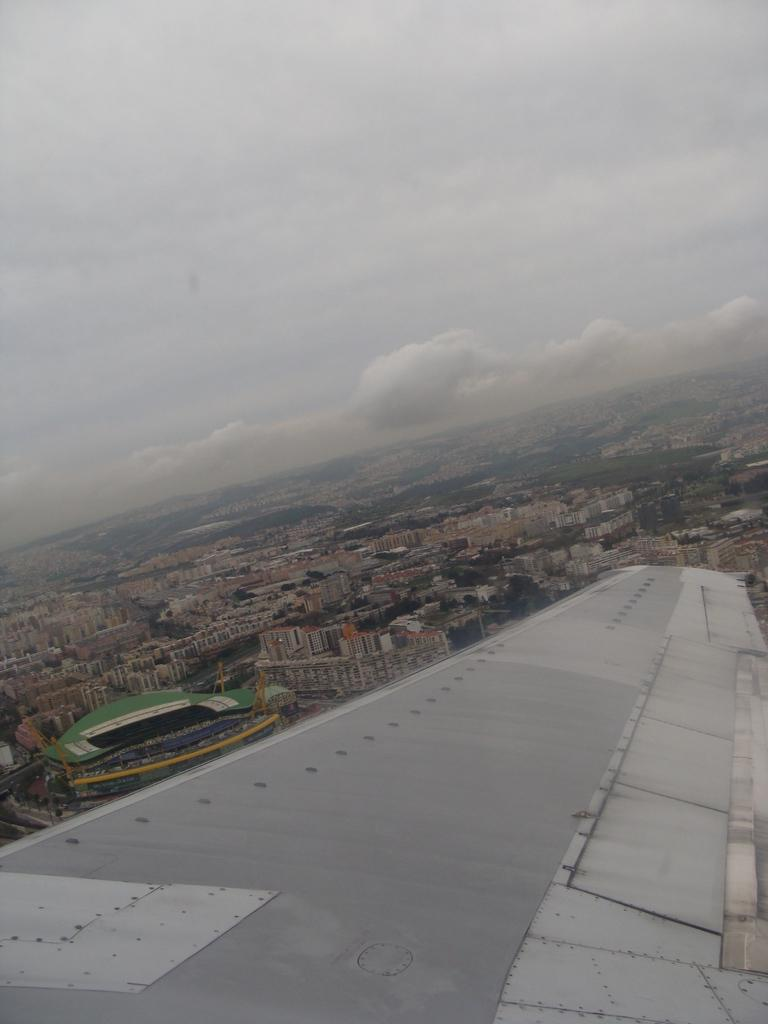What type of structures can be seen in the image? There are buildings in the image. What other natural elements are present in the image? There are trees in the image. Can you describe the white color object in the image? The white color object in the image is not specified, but it is mentioned as being present. What is visible in the background of the image? The sky is visible in the image, and it has a combination of white and blue colors. What type of voice can be heard coming from the can in the image? There is no can or voice present in the image. What is the yoke used for in the image? There is no yoke present in the image. 